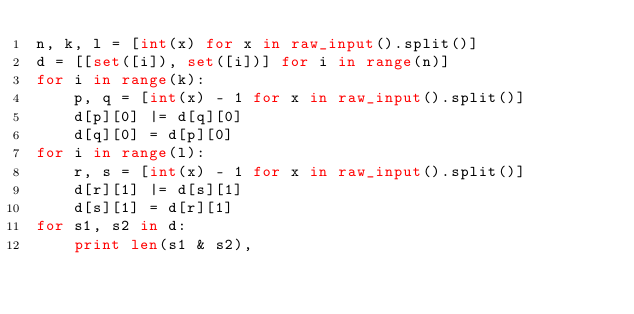Convert code to text. <code><loc_0><loc_0><loc_500><loc_500><_Python_>n, k, l = [int(x) for x in raw_input().split()]
d = [[set([i]), set([i])] for i in range(n)]
for i in range(k):
    p, q = [int(x) - 1 for x in raw_input().split()]
    d[p][0] |= d[q][0]
    d[q][0] = d[p][0]
for i in range(l):
    r, s = [int(x) - 1 for x in raw_input().split()]
    d[r][1] |= d[s][1]
    d[s][1] = d[r][1]
for s1, s2 in d:
    print len(s1 & s2),
</code> 